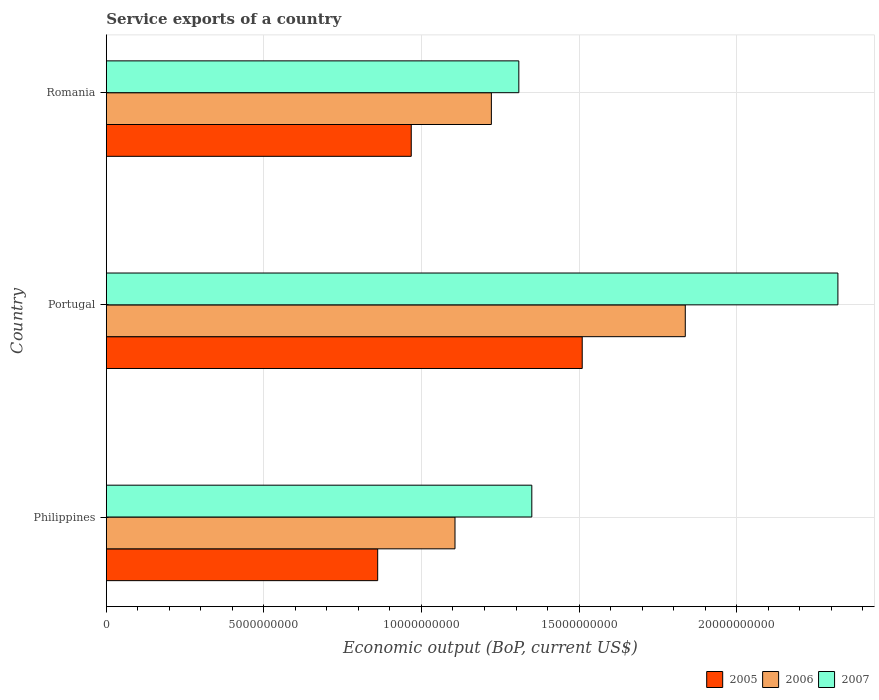Are the number of bars on each tick of the Y-axis equal?
Give a very brief answer. Yes. How many bars are there on the 3rd tick from the top?
Offer a very short reply. 3. How many bars are there on the 2nd tick from the bottom?
Offer a terse response. 3. What is the label of the 3rd group of bars from the top?
Provide a succinct answer. Philippines. In how many cases, is the number of bars for a given country not equal to the number of legend labels?
Keep it short and to the point. 0. What is the service exports in 2006 in Philippines?
Provide a succinct answer. 1.11e+1. Across all countries, what is the maximum service exports in 2007?
Provide a short and direct response. 2.32e+1. Across all countries, what is the minimum service exports in 2005?
Provide a succinct answer. 8.61e+09. In which country was the service exports in 2005 maximum?
Your answer should be very brief. Portugal. What is the total service exports in 2007 in the graph?
Keep it short and to the point. 4.98e+1. What is the difference between the service exports in 2005 in Portugal and that in Romania?
Provide a succinct answer. 5.43e+09. What is the difference between the service exports in 2007 in Romania and the service exports in 2006 in Philippines?
Ensure brevity in your answer.  2.03e+09. What is the average service exports in 2005 per country?
Provide a short and direct response. 1.11e+1. What is the difference between the service exports in 2006 and service exports in 2005 in Philippines?
Provide a short and direct response. 2.45e+09. In how many countries, is the service exports in 2006 greater than 1000000000 US$?
Give a very brief answer. 3. What is the ratio of the service exports in 2007 in Philippines to that in Portugal?
Offer a terse response. 0.58. Is the service exports in 2006 in Philippines less than that in Portugal?
Your answer should be very brief. Yes. What is the difference between the highest and the second highest service exports in 2007?
Give a very brief answer. 9.71e+09. What is the difference between the highest and the lowest service exports in 2006?
Give a very brief answer. 7.31e+09. Is the sum of the service exports in 2006 in Philippines and Romania greater than the maximum service exports in 2005 across all countries?
Give a very brief answer. Yes. What does the 3rd bar from the top in Romania represents?
Your answer should be compact. 2005. What does the 2nd bar from the bottom in Romania represents?
Give a very brief answer. 2006. Is it the case that in every country, the sum of the service exports in 2006 and service exports in 2007 is greater than the service exports in 2005?
Keep it short and to the point. Yes. Are all the bars in the graph horizontal?
Provide a short and direct response. Yes. How many countries are there in the graph?
Provide a short and direct response. 3. Are the values on the major ticks of X-axis written in scientific E-notation?
Offer a terse response. No. Does the graph contain any zero values?
Your answer should be very brief. No. Does the graph contain grids?
Offer a terse response. Yes. How many legend labels are there?
Give a very brief answer. 3. How are the legend labels stacked?
Give a very brief answer. Horizontal. What is the title of the graph?
Provide a succinct answer. Service exports of a country. Does "1994" appear as one of the legend labels in the graph?
Keep it short and to the point. No. What is the label or title of the X-axis?
Provide a short and direct response. Economic output (BoP, current US$). What is the Economic output (BoP, current US$) of 2005 in Philippines?
Provide a short and direct response. 8.61e+09. What is the Economic output (BoP, current US$) in 2006 in Philippines?
Make the answer very short. 1.11e+1. What is the Economic output (BoP, current US$) of 2007 in Philippines?
Provide a succinct answer. 1.35e+1. What is the Economic output (BoP, current US$) in 2005 in Portugal?
Offer a terse response. 1.51e+1. What is the Economic output (BoP, current US$) of 2006 in Portugal?
Provide a succinct answer. 1.84e+1. What is the Economic output (BoP, current US$) in 2007 in Portugal?
Provide a succinct answer. 2.32e+1. What is the Economic output (BoP, current US$) in 2005 in Romania?
Your response must be concise. 9.68e+09. What is the Economic output (BoP, current US$) in 2006 in Romania?
Your response must be concise. 1.22e+1. What is the Economic output (BoP, current US$) in 2007 in Romania?
Provide a succinct answer. 1.31e+1. Across all countries, what is the maximum Economic output (BoP, current US$) of 2005?
Keep it short and to the point. 1.51e+1. Across all countries, what is the maximum Economic output (BoP, current US$) in 2006?
Your answer should be compact. 1.84e+1. Across all countries, what is the maximum Economic output (BoP, current US$) in 2007?
Provide a short and direct response. 2.32e+1. Across all countries, what is the minimum Economic output (BoP, current US$) of 2005?
Ensure brevity in your answer.  8.61e+09. Across all countries, what is the minimum Economic output (BoP, current US$) in 2006?
Provide a succinct answer. 1.11e+1. Across all countries, what is the minimum Economic output (BoP, current US$) of 2007?
Offer a very short reply. 1.31e+1. What is the total Economic output (BoP, current US$) in 2005 in the graph?
Your answer should be compact. 3.34e+1. What is the total Economic output (BoP, current US$) of 2006 in the graph?
Keep it short and to the point. 4.17e+1. What is the total Economic output (BoP, current US$) of 2007 in the graph?
Ensure brevity in your answer.  4.98e+1. What is the difference between the Economic output (BoP, current US$) in 2005 in Philippines and that in Portugal?
Offer a very short reply. -6.49e+09. What is the difference between the Economic output (BoP, current US$) of 2006 in Philippines and that in Portugal?
Ensure brevity in your answer.  -7.31e+09. What is the difference between the Economic output (BoP, current US$) in 2007 in Philippines and that in Portugal?
Your answer should be compact. -9.71e+09. What is the difference between the Economic output (BoP, current US$) in 2005 in Philippines and that in Romania?
Ensure brevity in your answer.  -1.06e+09. What is the difference between the Economic output (BoP, current US$) of 2006 in Philippines and that in Romania?
Your answer should be compact. -1.15e+09. What is the difference between the Economic output (BoP, current US$) in 2007 in Philippines and that in Romania?
Your answer should be compact. 4.12e+08. What is the difference between the Economic output (BoP, current US$) in 2005 in Portugal and that in Romania?
Your answer should be very brief. 5.43e+09. What is the difference between the Economic output (BoP, current US$) in 2006 in Portugal and that in Romania?
Keep it short and to the point. 6.15e+09. What is the difference between the Economic output (BoP, current US$) in 2007 in Portugal and that in Romania?
Your response must be concise. 1.01e+1. What is the difference between the Economic output (BoP, current US$) in 2005 in Philippines and the Economic output (BoP, current US$) in 2006 in Portugal?
Your answer should be compact. -9.76e+09. What is the difference between the Economic output (BoP, current US$) of 2005 in Philippines and the Economic output (BoP, current US$) of 2007 in Portugal?
Your response must be concise. -1.46e+1. What is the difference between the Economic output (BoP, current US$) in 2006 in Philippines and the Economic output (BoP, current US$) in 2007 in Portugal?
Ensure brevity in your answer.  -1.22e+1. What is the difference between the Economic output (BoP, current US$) in 2005 in Philippines and the Economic output (BoP, current US$) in 2006 in Romania?
Your answer should be very brief. -3.61e+09. What is the difference between the Economic output (BoP, current US$) of 2005 in Philippines and the Economic output (BoP, current US$) of 2007 in Romania?
Provide a succinct answer. -4.48e+09. What is the difference between the Economic output (BoP, current US$) of 2006 in Philippines and the Economic output (BoP, current US$) of 2007 in Romania?
Provide a short and direct response. -2.03e+09. What is the difference between the Economic output (BoP, current US$) of 2005 in Portugal and the Economic output (BoP, current US$) of 2006 in Romania?
Provide a succinct answer. 2.88e+09. What is the difference between the Economic output (BoP, current US$) in 2005 in Portugal and the Economic output (BoP, current US$) in 2007 in Romania?
Keep it short and to the point. 2.01e+09. What is the difference between the Economic output (BoP, current US$) of 2006 in Portugal and the Economic output (BoP, current US$) of 2007 in Romania?
Give a very brief answer. 5.28e+09. What is the average Economic output (BoP, current US$) in 2005 per country?
Ensure brevity in your answer.  1.11e+1. What is the average Economic output (BoP, current US$) in 2006 per country?
Ensure brevity in your answer.  1.39e+1. What is the average Economic output (BoP, current US$) in 2007 per country?
Your answer should be compact. 1.66e+1. What is the difference between the Economic output (BoP, current US$) of 2005 and Economic output (BoP, current US$) of 2006 in Philippines?
Make the answer very short. -2.45e+09. What is the difference between the Economic output (BoP, current US$) in 2005 and Economic output (BoP, current US$) in 2007 in Philippines?
Your answer should be very brief. -4.89e+09. What is the difference between the Economic output (BoP, current US$) in 2006 and Economic output (BoP, current US$) in 2007 in Philippines?
Ensure brevity in your answer.  -2.44e+09. What is the difference between the Economic output (BoP, current US$) of 2005 and Economic output (BoP, current US$) of 2006 in Portugal?
Keep it short and to the point. -3.27e+09. What is the difference between the Economic output (BoP, current US$) of 2005 and Economic output (BoP, current US$) of 2007 in Portugal?
Provide a short and direct response. -8.11e+09. What is the difference between the Economic output (BoP, current US$) in 2006 and Economic output (BoP, current US$) in 2007 in Portugal?
Your response must be concise. -4.84e+09. What is the difference between the Economic output (BoP, current US$) in 2005 and Economic output (BoP, current US$) in 2006 in Romania?
Provide a short and direct response. -2.54e+09. What is the difference between the Economic output (BoP, current US$) in 2005 and Economic output (BoP, current US$) in 2007 in Romania?
Make the answer very short. -3.41e+09. What is the difference between the Economic output (BoP, current US$) of 2006 and Economic output (BoP, current US$) of 2007 in Romania?
Offer a very short reply. -8.71e+08. What is the ratio of the Economic output (BoP, current US$) of 2005 in Philippines to that in Portugal?
Ensure brevity in your answer.  0.57. What is the ratio of the Economic output (BoP, current US$) of 2006 in Philippines to that in Portugal?
Offer a terse response. 0.6. What is the ratio of the Economic output (BoP, current US$) in 2007 in Philippines to that in Portugal?
Provide a short and direct response. 0.58. What is the ratio of the Economic output (BoP, current US$) of 2005 in Philippines to that in Romania?
Your answer should be compact. 0.89. What is the ratio of the Economic output (BoP, current US$) of 2006 in Philippines to that in Romania?
Offer a terse response. 0.91. What is the ratio of the Economic output (BoP, current US$) of 2007 in Philippines to that in Romania?
Offer a very short reply. 1.03. What is the ratio of the Economic output (BoP, current US$) in 2005 in Portugal to that in Romania?
Your answer should be compact. 1.56. What is the ratio of the Economic output (BoP, current US$) in 2006 in Portugal to that in Romania?
Your response must be concise. 1.5. What is the ratio of the Economic output (BoP, current US$) of 2007 in Portugal to that in Romania?
Your answer should be compact. 1.77. What is the difference between the highest and the second highest Economic output (BoP, current US$) in 2005?
Your answer should be very brief. 5.43e+09. What is the difference between the highest and the second highest Economic output (BoP, current US$) in 2006?
Ensure brevity in your answer.  6.15e+09. What is the difference between the highest and the second highest Economic output (BoP, current US$) in 2007?
Ensure brevity in your answer.  9.71e+09. What is the difference between the highest and the lowest Economic output (BoP, current US$) of 2005?
Give a very brief answer. 6.49e+09. What is the difference between the highest and the lowest Economic output (BoP, current US$) in 2006?
Provide a succinct answer. 7.31e+09. What is the difference between the highest and the lowest Economic output (BoP, current US$) in 2007?
Ensure brevity in your answer.  1.01e+1. 